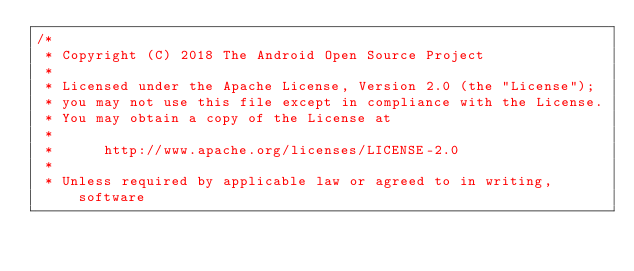<code> <loc_0><loc_0><loc_500><loc_500><_C++_>/*
 * Copyright (C) 2018 The Android Open Source Project
 *
 * Licensed under the Apache License, Version 2.0 (the "License");
 * you may not use this file except in compliance with the License.
 * You may obtain a copy of the License at
 *
 *      http://www.apache.org/licenses/LICENSE-2.0
 *
 * Unless required by applicable law or agreed to in writing, software</code> 